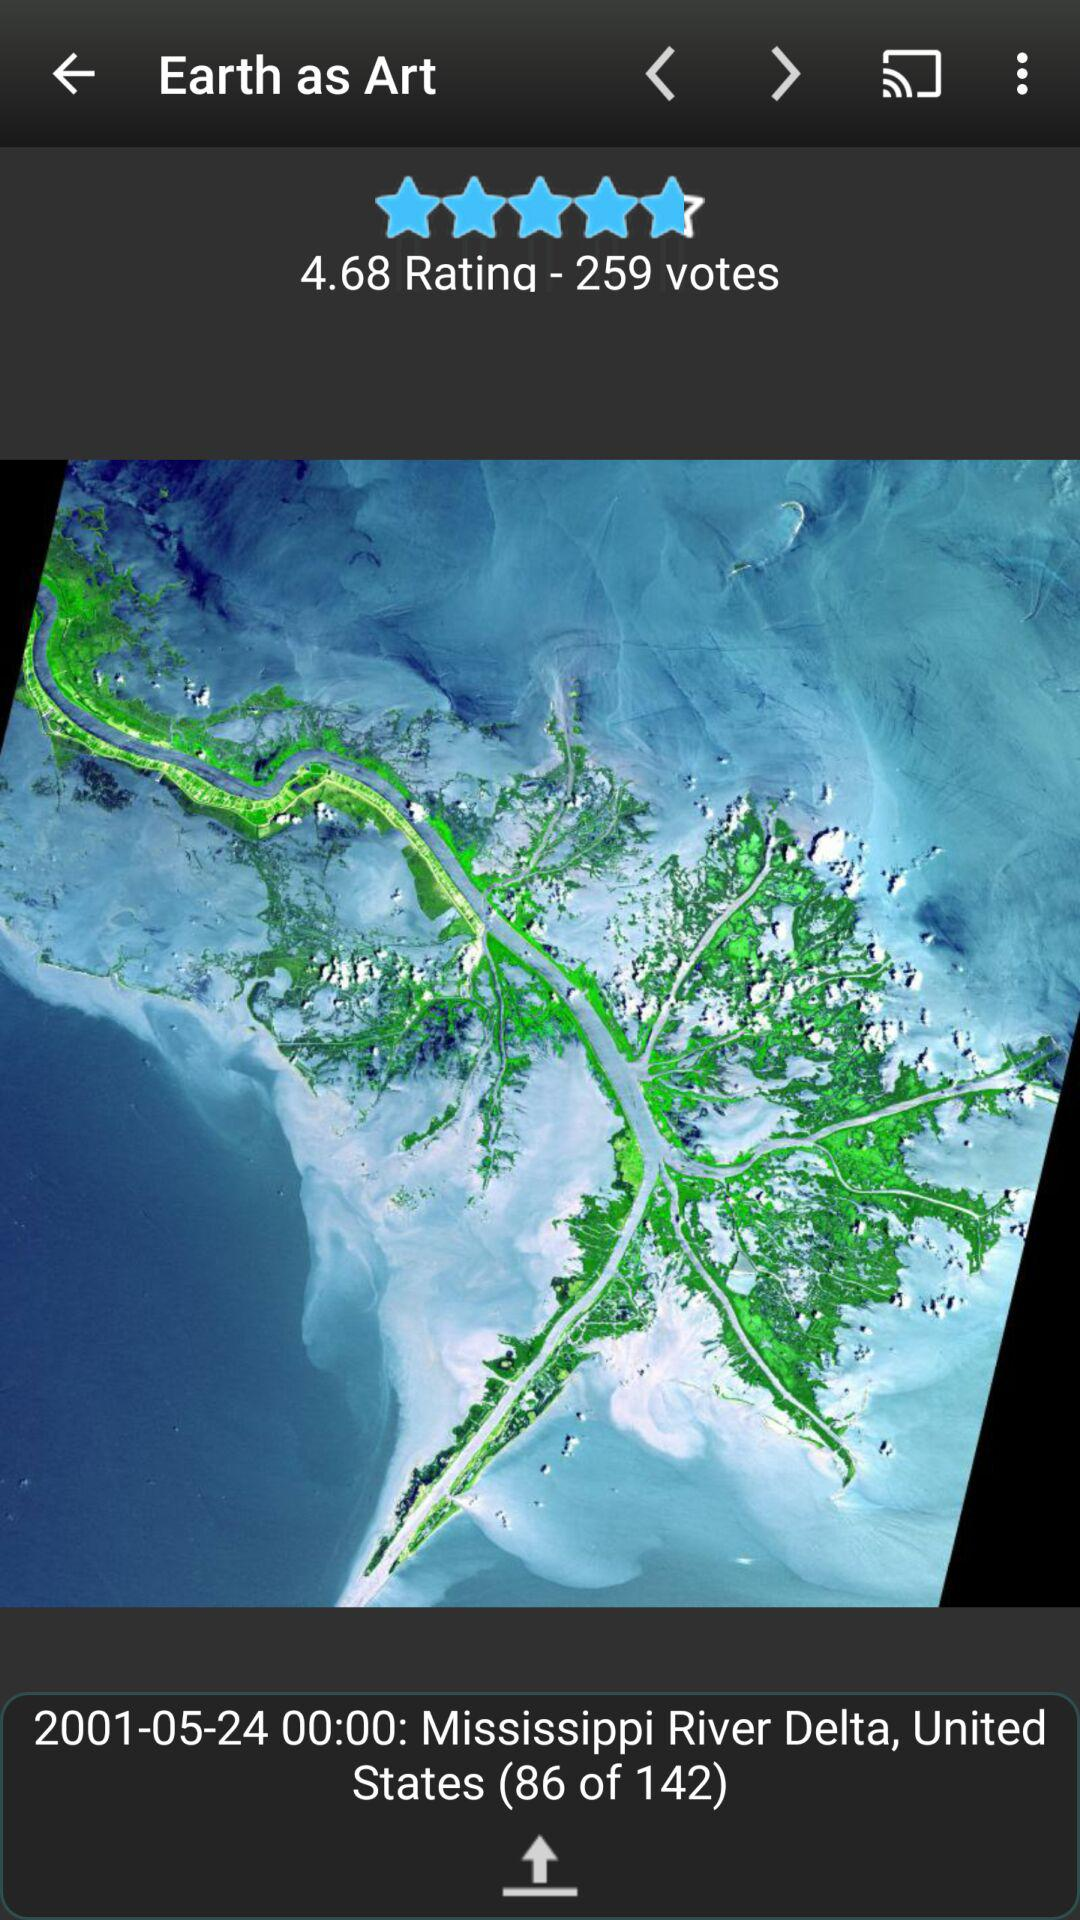What is the location? The location is the Mississippi River Delta, United States. 